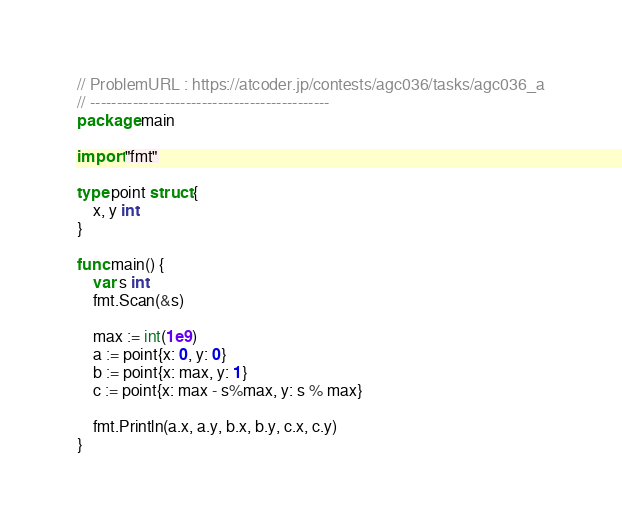Convert code to text. <code><loc_0><loc_0><loc_500><loc_500><_Go_>// ProblemURL : https://atcoder.jp/contests/agc036/tasks/agc036_a
// ---------------------------------------------
package main

import "fmt"

type point struct {
	x, y int
}

func main() {
	var s int
	fmt.Scan(&s)

	max := int(1e9)
	a := point{x: 0, y: 0}
	b := point{x: max, y: 1}
	c := point{x: max - s%max, y: s % max}

	fmt.Println(a.x, a.y, b.x, b.y, c.x, c.y)
}
</code> 